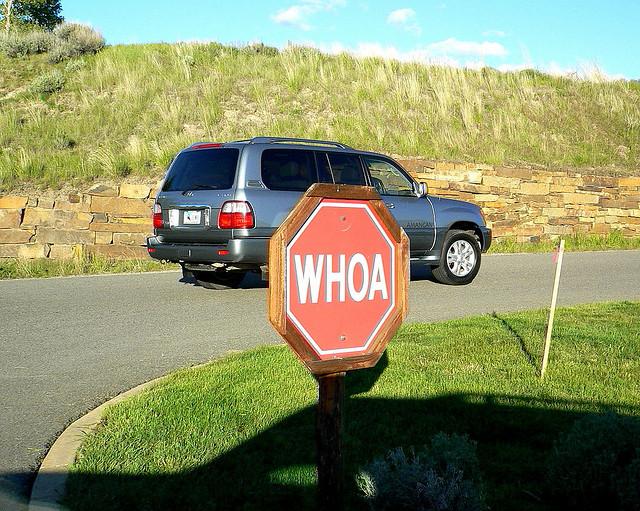What shape is sign?
Quick response, please. Octagon. What is the sign saying?
Quick response, please. Whoa. Is there are stone wall?
Give a very brief answer. Yes. 